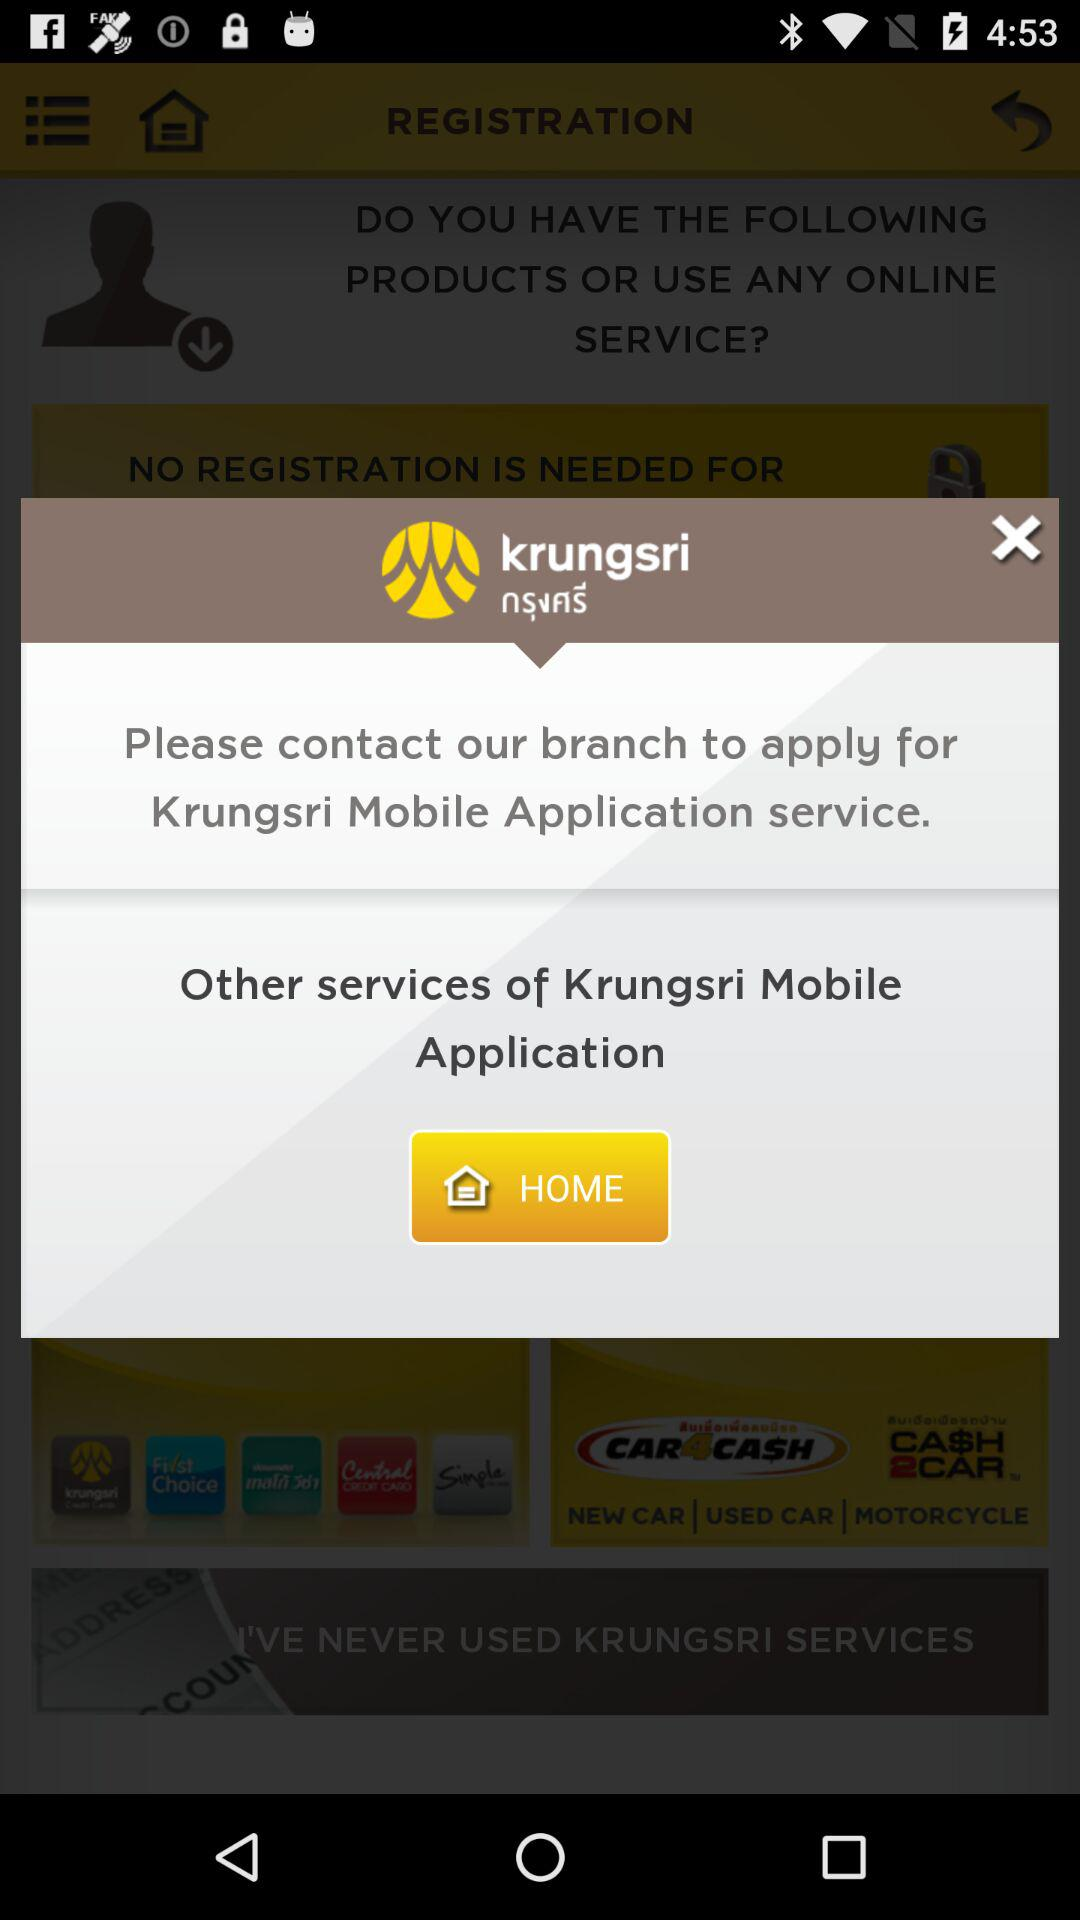What is the contact number for the branch?
When the provided information is insufficient, respond with <no answer>. <no answer> 